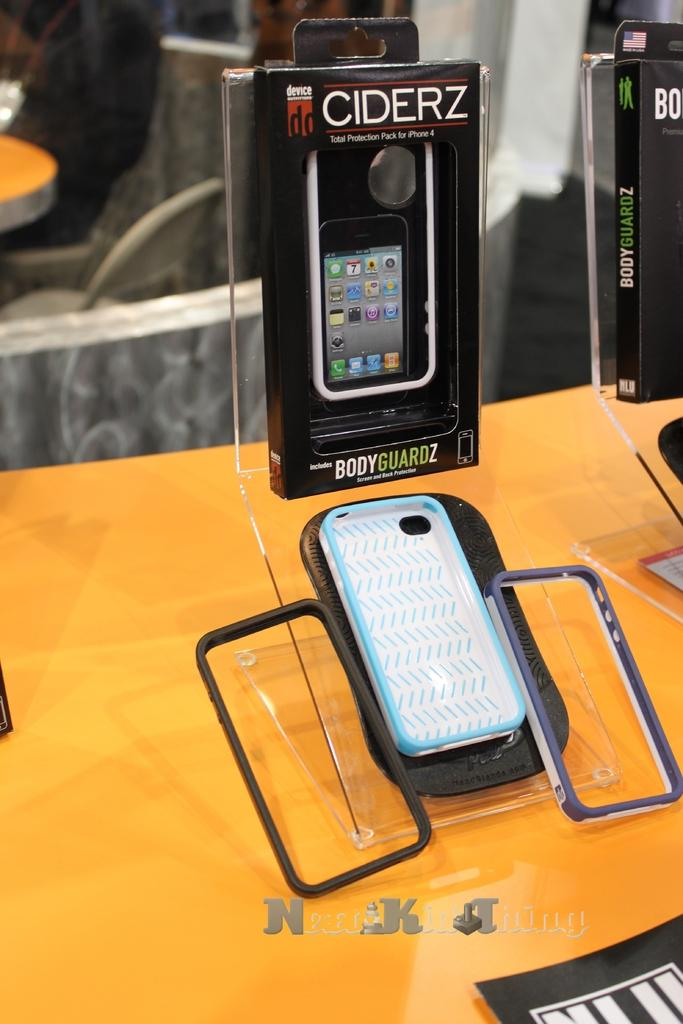What object is the main focus of the image? The main focus of the image is a phone cover. Where is the phone cover located? The phone cover is on a table. What can be seen in the background of the image? There are chairs in the background of the image. What type of wheel is depicted on the phone cover? There is no wheel depicted on the phone cover; it is a phone accessory. 